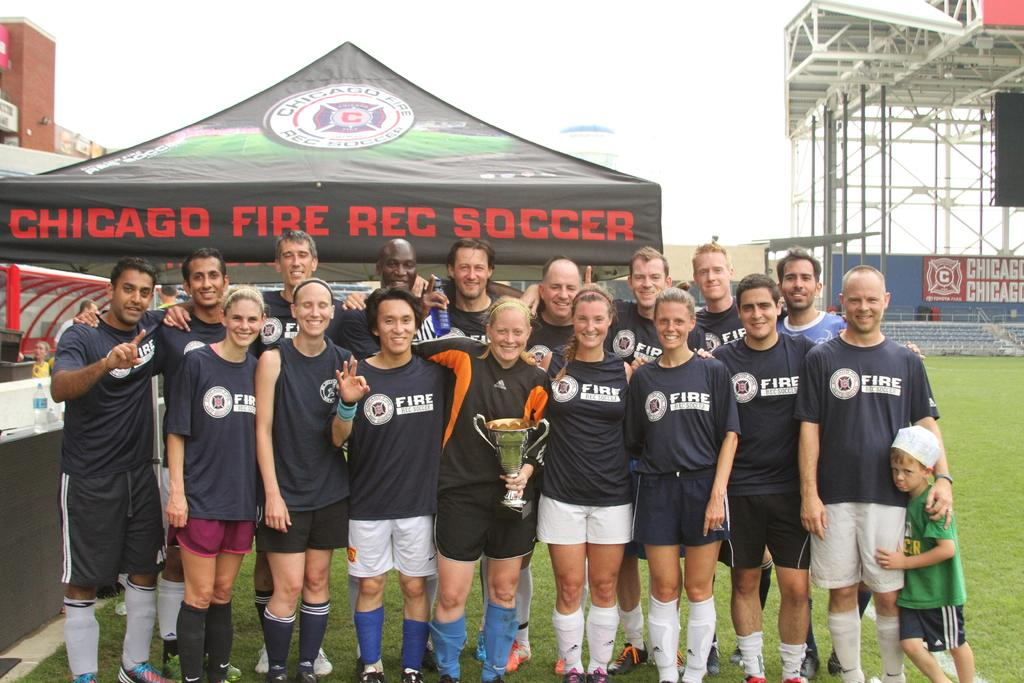Provide a one-sentence caption for the provided image. The Chicago Fire Rec Soccer team poses with a trophy. 